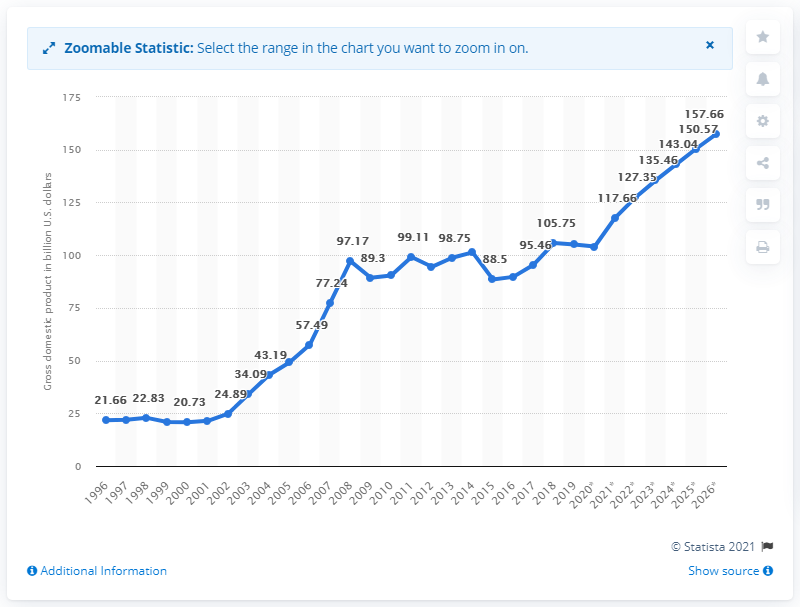List a handful of essential elements in this visual. In 2019, Slovakia's gross domestic product was 104.09. 